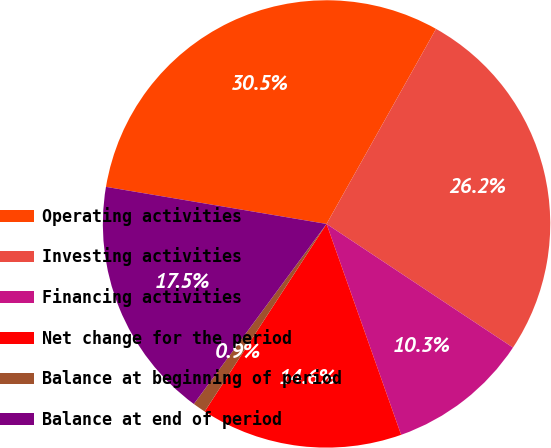Convert chart. <chart><loc_0><loc_0><loc_500><loc_500><pie_chart><fcel>Operating activities<fcel>Investing activities<fcel>Financing activities<fcel>Net change for the period<fcel>Balance at beginning of period<fcel>Balance at end of period<nl><fcel>30.49%<fcel>26.18%<fcel>10.27%<fcel>14.58%<fcel>0.94%<fcel>17.54%<nl></chart> 